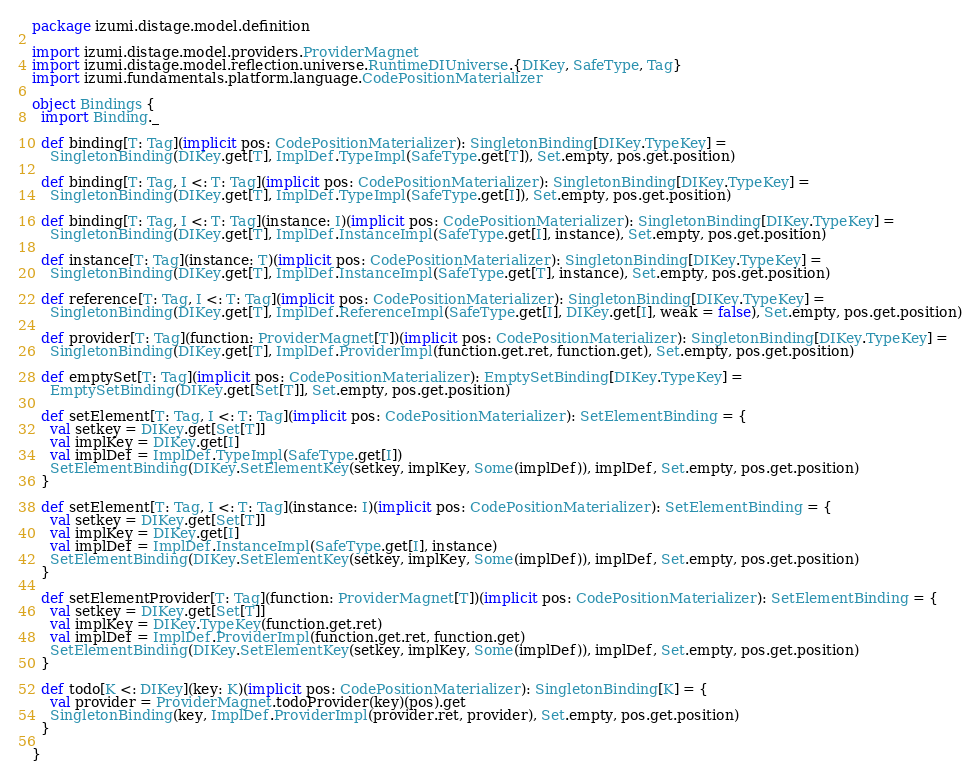Convert code to text. <code><loc_0><loc_0><loc_500><loc_500><_Scala_>package izumi.distage.model.definition

import izumi.distage.model.providers.ProviderMagnet
import izumi.distage.model.reflection.universe.RuntimeDIUniverse.{DIKey, SafeType, Tag}
import izumi.fundamentals.platform.language.CodePositionMaterializer

object Bindings {
  import Binding._

  def binding[T: Tag](implicit pos: CodePositionMaterializer): SingletonBinding[DIKey.TypeKey] =
    SingletonBinding(DIKey.get[T], ImplDef.TypeImpl(SafeType.get[T]), Set.empty, pos.get.position)

  def binding[T: Tag, I <: T: Tag](implicit pos: CodePositionMaterializer): SingletonBinding[DIKey.TypeKey] =
    SingletonBinding(DIKey.get[T], ImplDef.TypeImpl(SafeType.get[I]), Set.empty, pos.get.position)

  def binding[T: Tag, I <: T: Tag](instance: I)(implicit pos: CodePositionMaterializer): SingletonBinding[DIKey.TypeKey] =
    SingletonBinding(DIKey.get[T], ImplDef.InstanceImpl(SafeType.get[I], instance), Set.empty, pos.get.position)

  def instance[T: Tag](instance: T)(implicit pos: CodePositionMaterializer): SingletonBinding[DIKey.TypeKey] =
    SingletonBinding(DIKey.get[T], ImplDef.InstanceImpl(SafeType.get[T], instance), Set.empty, pos.get.position)

  def reference[T: Tag, I <: T: Tag](implicit pos: CodePositionMaterializer): SingletonBinding[DIKey.TypeKey] =
    SingletonBinding(DIKey.get[T], ImplDef.ReferenceImpl(SafeType.get[I], DIKey.get[I], weak = false), Set.empty, pos.get.position)

  def provider[T: Tag](function: ProviderMagnet[T])(implicit pos: CodePositionMaterializer): SingletonBinding[DIKey.TypeKey] =
    SingletonBinding(DIKey.get[T], ImplDef.ProviderImpl(function.get.ret, function.get), Set.empty, pos.get.position)

  def emptySet[T: Tag](implicit pos: CodePositionMaterializer): EmptySetBinding[DIKey.TypeKey] =
    EmptySetBinding(DIKey.get[Set[T]], Set.empty, pos.get.position)

  def setElement[T: Tag, I <: T: Tag](implicit pos: CodePositionMaterializer): SetElementBinding = {
    val setkey = DIKey.get[Set[T]]
    val implKey = DIKey.get[I]
    val implDef = ImplDef.TypeImpl(SafeType.get[I])
    SetElementBinding(DIKey.SetElementKey(setkey, implKey, Some(implDef)), implDef, Set.empty, pos.get.position)
  }

  def setElement[T: Tag, I <: T: Tag](instance: I)(implicit pos: CodePositionMaterializer): SetElementBinding = {
    val setkey = DIKey.get[Set[T]]
    val implKey = DIKey.get[I]
    val implDef = ImplDef.InstanceImpl(SafeType.get[I], instance)
    SetElementBinding(DIKey.SetElementKey(setkey, implKey, Some(implDef)), implDef, Set.empty, pos.get.position)
  }

  def setElementProvider[T: Tag](function: ProviderMagnet[T])(implicit pos: CodePositionMaterializer): SetElementBinding = {
    val setkey = DIKey.get[Set[T]]
    val implKey = DIKey.TypeKey(function.get.ret)
    val implDef = ImplDef.ProviderImpl(function.get.ret, function.get)
    SetElementBinding(DIKey.SetElementKey(setkey, implKey, Some(implDef)), implDef, Set.empty, pos.get.position)
  }

  def todo[K <: DIKey](key: K)(implicit pos: CodePositionMaterializer): SingletonBinding[K] = {
    val provider = ProviderMagnet.todoProvider(key)(pos).get
    SingletonBinding(key, ImplDef.ProviderImpl(provider.ret, provider), Set.empty, pos.get.position)
  }

}
</code> 